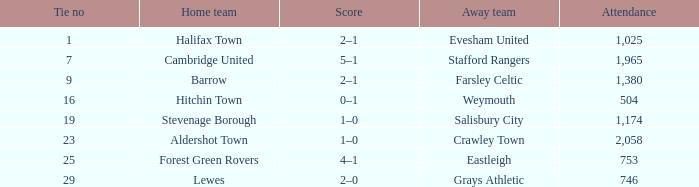What is the highest attendance for games with stevenage borough at home? 1174.0. 